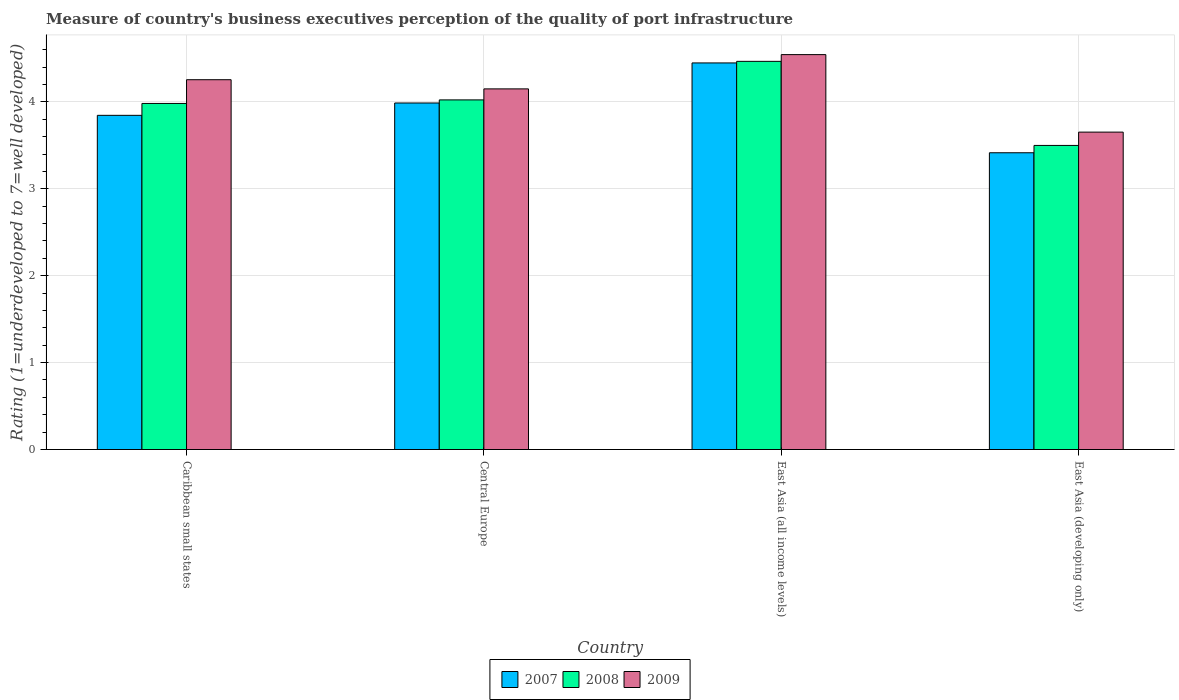How many groups of bars are there?
Your response must be concise. 4. How many bars are there on the 1st tick from the right?
Make the answer very short. 3. What is the label of the 4th group of bars from the left?
Give a very brief answer. East Asia (developing only). In how many cases, is the number of bars for a given country not equal to the number of legend labels?
Give a very brief answer. 0. What is the ratings of the quality of port infrastructure in 2008 in Caribbean small states?
Keep it short and to the point. 3.98. Across all countries, what is the maximum ratings of the quality of port infrastructure in 2007?
Make the answer very short. 4.45. Across all countries, what is the minimum ratings of the quality of port infrastructure in 2007?
Provide a succinct answer. 3.41. In which country was the ratings of the quality of port infrastructure in 2009 maximum?
Offer a terse response. East Asia (all income levels). In which country was the ratings of the quality of port infrastructure in 2007 minimum?
Make the answer very short. East Asia (developing only). What is the total ratings of the quality of port infrastructure in 2008 in the graph?
Your answer should be very brief. 15.97. What is the difference between the ratings of the quality of port infrastructure in 2009 in East Asia (all income levels) and that in East Asia (developing only)?
Provide a succinct answer. 0.89. What is the difference between the ratings of the quality of port infrastructure in 2007 in Central Europe and the ratings of the quality of port infrastructure in 2009 in East Asia (developing only)?
Your answer should be compact. 0.33. What is the average ratings of the quality of port infrastructure in 2008 per country?
Offer a very short reply. 3.99. What is the difference between the ratings of the quality of port infrastructure of/in 2009 and ratings of the quality of port infrastructure of/in 2008 in Caribbean small states?
Your response must be concise. 0.27. In how many countries, is the ratings of the quality of port infrastructure in 2009 greater than 2.8?
Offer a terse response. 4. What is the ratio of the ratings of the quality of port infrastructure in 2008 in Caribbean small states to that in Central Europe?
Provide a short and direct response. 0.99. What is the difference between the highest and the second highest ratings of the quality of port infrastructure in 2008?
Your answer should be compact. -0.48. What is the difference between the highest and the lowest ratings of the quality of port infrastructure in 2009?
Offer a very short reply. 0.89. What does the 3rd bar from the left in Central Europe represents?
Provide a short and direct response. 2009. What does the 2nd bar from the right in Central Europe represents?
Your answer should be very brief. 2008. Is it the case that in every country, the sum of the ratings of the quality of port infrastructure in 2009 and ratings of the quality of port infrastructure in 2007 is greater than the ratings of the quality of port infrastructure in 2008?
Your answer should be very brief. Yes. How many bars are there?
Keep it short and to the point. 12. How many countries are there in the graph?
Ensure brevity in your answer.  4. What is the difference between two consecutive major ticks on the Y-axis?
Offer a very short reply. 1. Does the graph contain any zero values?
Your answer should be compact. No. Does the graph contain grids?
Ensure brevity in your answer.  Yes. Where does the legend appear in the graph?
Your response must be concise. Bottom center. How are the legend labels stacked?
Offer a very short reply. Horizontal. What is the title of the graph?
Your response must be concise. Measure of country's business executives perception of the quality of port infrastructure. What is the label or title of the X-axis?
Make the answer very short. Country. What is the label or title of the Y-axis?
Offer a terse response. Rating (1=underdeveloped to 7=well developed). What is the Rating (1=underdeveloped to 7=well developed) of 2007 in Caribbean small states?
Offer a terse response. 3.85. What is the Rating (1=underdeveloped to 7=well developed) of 2008 in Caribbean small states?
Ensure brevity in your answer.  3.98. What is the Rating (1=underdeveloped to 7=well developed) in 2009 in Caribbean small states?
Your response must be concise. 4.26. What is the Rating (1=underdeveloped to 7=well developed) of 2007 in Central Europe?
Give a very brief answer. 3.99. What is the Rating (1=underdeveloped to 7=well developed) of 2008 in Central Europe?
Your response must be concise. 4.02. What is the Rating (1=underdeveloped to 7=well developed) of 2009 in Central Europe?
Provide a short and direct response. 4.15. What is the Rating (1=underdeveloped to 7=well developed) in 2007 in East Asia (all income levels)?
Provide a succinct answer. 4.45. What is the Rating (1=underdeveloped to 7=well developed) in 2008 in East Asia (all income levels)?
Keep it short and to the point. 4.47. What is the Rating (1=underdeveloped to 7=well developed) of 2009 in East Asia (all income levels)?
Your answer should be very brief. 4.54. What is the Rating (1=underdeveloped to 7=well developed) in 2007 in East Asia (developing only)?
Ensure brevity in your answer.  3.41. What is the Rating (1=underdeveloped to 7=well developed) in 2008 in East Asia (developing only)?
Keep it short and to the point. 3.5. What is the Rating (1=underdeveloped to 7=well developed) of 2009 in East Asia (developing only)?
Your answer should be compact. 3.65. Across all countries, what is the maximum Rating (1=underdeveloped to 7=well developed) in 2007?
Keep it short and to the point. 4.45. Across all countries, what is the maximum Rating (1=underdeveloped to 7=well developed) of 2008?
Offer a very short reply. 4.47. Across all countries, what is the maximum Rating (1=underdeveloped to 7=well developed) of 2009?
Offer a very short reply. 4.54. Across all countries, what is the minimum Rating (1=underdeveloped to 7=well developed) of 2007?
Give a very brief answer. 3.41. Across all countries, what is the minimum Rating (1=underdeveloped to 7=well developed) in 2008?
Offer a terse response. 3.5. Across all countries, what is the minimum Rating (1=underdeveloped to 7=well developed) in 2009?
Provide a succinct answer. 3.65. What is the total Rating (1=underdeveloped to 7=well developed) of 2007 in the graph?
Offer a very short reply. 15.7. What is the total Rating (1=underdeveloped to 7=well developed) in 2008 in the graph?
Your answer should be very brief. 15.97. What is the total Rating (1=underdeveloped to 7=well developed) of 2009 in the graph?
Provide a succinct answer. 16.6. What is the difference between the Rating (1=underdeveloped to 7=well developed) of 2007 in Caribbean small states and that in Central Europe?
Your answer should be compact. -0.14. What is the difference between the Rating (1=underdeveloped to 7=well developed) in 2008 in Caribbean small states and that in Central Europe?
Give a very brief answer. -0.04. What is the difference between the Rating (1=underdeveloped to 7=well developed) in 2009 in Caribbean small states and that in Central Europe?
Provide a succinct answer. 0.11. What is the difference between the Rating (1=underdeveloped to 7=well developed) in 2007 in Caribbean small states and that in East Asia (all income levels)?
Offer a very short reply. -0.6. What is the difference between the Rating (1=underdeveloped to 7=well developed) in 2008 in Caribbean small states and that in East Asia (all income levels)?
Keep it short and to the point. -0.48. What is the difference between the Rating (1=underdeveloped to 7=well developed) in 2009 in Caribbean small states and that in East Asia (all income levels)?
Provide a succinct answer. -0.29. What is the difference between the Rating (1=underdeveloped to 7=well developed) in 2007 in Caribbean small states and that in East Asia (developing only)?
Offer a very short reply. 0.43. What is the difference between the Rating (1=underdeveloped to 7=well developed) of 2008 in Caribbean small states and that in East Asia (developing only)?
Ensure brevity in your answer.  0.48. What is the difference between the Rating (1=underdeveloped to 7=well developed) of 2009 in Caribbean small states and that in East Asia (developing only)?
Give a very brief answer. 0.6. What is the difference between the Rating (1=underdeveloped to 7=well developed) in 2007 in Central Europe and that in East Asia (all income levels)?
Keep it short and to the point. -0.46. What is the difference between the Rating (1=underdeveloped to 7=well developed) in 2008 in Central Europe and that in East Asia (all income levels)?
Keep it short and to the point. -0.44. What is the difference between the Rating (1=underdeveloped to 7=well developed) of 2009 in Central Europe and that in East Asia (all income levels)?
Your response must be concise. -0.39. What is the difference between the Rating (1=underdeveloped to 7=well developed) of 2007 in Central Europe and that in East Asia (developing only)?
Ensure brevity in your answer.  0.57. What is the difference between the Rating (1=underdeveloped to 7=well developed) in 2008 in Central Europe and that in East Asia (developing only)?
Provide a short and direct response. 0.52. What is the difference between the Rating (1=underdeveloped to 7=well developed) in 2009 in Central Europe and that in East Asia (developing only)?
Provide a short and direct response. 0.5. What is the difference between the Rating (1=underdeveloped to 7=well developed) of 2007 in East Asia (all income levels) and that in East Asia (developing only)?
Your answer should be very brief. 1.03. What is the difference between the Rating (1=underdeveloped to 7=well developed) in 2008 in East Asia (all income levels) and that in East Asia (developing only)?
Keep it short and to the point. 0.97. What is the difference between the Rating (1=underdeveloped to 7=well developed) of 2009 in East Asia (all income levels) and that in East Asia (developing only)?
Keep it short and to the point. 0.89. What is the difference between the Rating (1=underdeveloped to 7=well developed) in 2007 in Caribbean small states and the Rating (1=underdeveloped to 7=well developed) in 2008 in Central Europe?
Provide a short and direct response. -0.18. What is the difference between the Rating (1=underdeveloped to 7=well developed) of 2007 in Caribbean small states and the Rating (1=underdeveloped to 7=well developed) of 2009 in Central Europe?
Provide a succinct answer. -0.3. What is the difference between the Rating (1=underdeveloped to 7=well developed) in 2008 in Caribbean small states and the Rating (1=underdeveloped to 7=well developed) in 2009 in Central Europe?
Your answer should be compact. -0.17. What is the difference between the Rating (1=underdeveloped to 7=well developed) of 2007 in Caribbean small states and the Rating (1=underdeveloped to 7=well developed) of 2008 in East Asia (all income levels)?
Provide a succinct answer. -0.62. What is the difference between the Rating (1=underdeveloped to 7=well developed) in 2007 in Caribbean small states and the Rating (1=underdeveloped to 7=well developed) in 2009 in East Asia (all income levels)?
Provide a short and direct response. -0.7. What is the difference between the Rating (1=underdeveloped to 7=well developed) in 2008 in Caribbean small states and the Rating (1=underdeveloped to 7=well developed) in 2009 in East Asia (all income levels)?
Offer a very short reply. -0.56. What is the difference between the Rating (1=underdeveloped to 7=well developed) of 2007 in Caribbean small states and the Rating (1=underdeveloped to 7=well developed) of 2008 in East Asia (developing only)?
Make the answer very short. 0.35. What is the difference between the Rating (1=underdeveloped to 7=well developed) in 2007 in Caribbean small states and the Rating (1=underdeveloped to 7=well developed) in 2009 in East Asia (developing only)?
Give a very brief answer. 0.19. What is the difference between the Rating (1=underdeveloped to 7=well developed) in 2008 in Caribbean small states and the Rating (1=underdeveloped to 7=well developed) in 2009 in East Asia (developing only)?
Offer a very short reply. 0.33. What is the difference between the Rating (1=underdeveloped to 7=well developed) in 2007 in Central Europe and the Rating (1=underdeveloped to 7=well developed) in 2008 in East Asia (all income levels)?
Your response must be concise. -0.48. What is the difference between the Rating (1=underdeveloped to 7=well developed) in 2007 in Central Europe and the Rating (1=underdeveloped to 7=well developed) in 2009 in East Asia (all income levels)?
Your response must be concise. -0.56. What is the difference between the Rating (1=underdeveloped to 7=well developed) in 2008 in Central Europe and the Rating (1=underdeveloped to 7=well developed) in 2009 in East Asia (all income levels)?
Provide a succinct answer. -0.52. What is the difference between the Rating (1=underdeveloped to 7=well developed) in 2007 in Central Europe and the Rating (1=underdeveloped to 7=well developed) in 2008 in East Asia (developing only)?
Your response must be concise. 0.49. What is the difference between the Rating (1=underdeveloped to 7=well developed) of 2007 in Central Europe and the Rating (1=underdeveloped to 7=well developed) of 2009 in East Asia (developing only)?
Give a very brief answer. 0.34. What is the difference between the Rating (1=underdeveloped to 7=well developed) of 2008 in Central Europe and the Rating (1=underdeveloped to 7=well developed) of 2009 in East Asia (developing only)?
Offer a very short reply. 0.37. What is the difference between the Rating (1=underdeveloped to 7=well developed) of 2007 in East Asia (all income levels) and the Rating (1=underdeveloped to 7=well developed) of 2008 in East Asia (developing only)?
Your answer should be very brief. 0.95. What is the difference between the Rating (1=underdeveloped to 7=well developed) in 2007 in East Asia (all income levels) and the Rating (1=underdeveloped to 7=well developed) in 2009 in East Asia (developing only)?
Your response must be concise. 0.8. What is the difference between the Rating (1=underdeveloped to 7=well developed) in 2008 in East Asia (all income levels) and the Rating (1=underdeveloped to 7=well developed) in 2009 in East Asia (developing only)?
Offer a terse response. 0.81. What is the average Rating (1=underdeveloped to 7=well developed) of 2007 per country?
Keep it short and to the point. 3.92. What is the average Rating (1=underdeveloped to 7=well developed) in 2008 per country?
Offer a terse response. 3.99. What is the average Rating (1=underdeveloped to 7=well developed) of 2009 per country?
Offer a very short reply. 4.15. What is the difference between the Rating (1=underdeveloped to 7=well developed) of 2007 and Rating (1=underdeveloped to 7=well developed) of 2008 in Caribbean small states?
Offer a very short reply. -0.14. What is the difference between the Rating (1=underdeveloped to 7=well developed) in 2007 and Rating (1=underdeveloped to 7=well developed) in 2009 in Caribbean small states?
Offer a very short reply. -0.41. What is the difference between the Rating (1=underdeveloped to 7=well developed) of 2008 and Rating (1=underdeveloped to 7=well developed) of 2009 in Caribbean small states?
Provide a succinct answer. -0.27. What is the difference between the Rating (1=underdeveloped to 7=well developed) in 2007 and Rating (1=underdeveloped to 7=well developed) in 2008 in Central Europe?
Offer a terse response. -0.04. What is the difference between the Rating (1=underdeveloped to 7=well developed) in 2007 and Rating (1=underdeveloped to 7=well developed) in 2009 in Central Europe?
Ensure brevity in your answer.  -0.16. What is the difference between the Rating (1=underdeveloped to 7=well developed) of 2008 and Rating (1=underdeveloped to 7=well developed) of 2009 in Central Europe?
Your response must be concise. -0.13. What is the difference between the Rating (1=underdeveloped to 7=well developed) of 2007 and Rating (1=underdeveloped to 7=well developed) of 2008 in East Asia (all income levels)?
Keep it short and to the point. -0.02. What is the difference between the Rating (1=underdeveloped to 7=well developed) in 2007 and Rating (1=underdeveloped to 7=well developed) in 2009 in East Asia (all income levels)?
Provide a succinct answer. -0.1. What is the difference between the Rating (1=underdeveloped to 7=well developed) in 2008 and Rating (1=underdeveloped to 7=well developed) in 2009 in East Asia (all income levels)?
Ensure brevity in your answer.  -0.08. What is the difference between the Rating (1=underdeveloped to 7=well developed) of 2007 and Rating (1=underdeveloped to 7=well developed) of 2008 in East Asia (developing only)?
Make the answer very short. -0.08. What is the difference between the Rating (1=underdeveloped to 7=well developed) in 2007 and Rating (1=underdeveloped to 7=well developed) in 2009 in East Asia (developing only)?
Your answer should be very brief. -0.24. What is the difference between the Rating (1=underdeveloped to 7=well developed) of 2008 and Rating (1=underdeveloped to 7=well developed) of 2009 in East Asia (developing only)?
Give a very brief answer. -0.15. What is the ratio of the Rating (1=underdeveloped to 7=well developed) in 2007 in Caribbean small states to that in Central Europe?
Your answer should be compact. 0.96. What is the ratio of the Rating (1=underdeveloped to 7=well developed) of 2008 in Caribbean small states to that in Central Europe?
Offer a very short reply. 0.99. What is the ratio of the Rating (1=underdeveloped to 7=well developed) in 2009 in Caribbean small states to that in Central Europe?
Offer a very short reply. 1.03. What is the ratio of the Rating (1=underdeveloped to 7=well developed) of 2007 in Caribbean small states to that in East Asia (all income levels)?
Offer a terse response. 0.86. What is the ratio of the Rating (1=underdeveloped to 7=well developed) in 2008 in Caribbean small states to that in East Asia (all income levels)?
Make the answer very short. 0.89. What is the ratio of the Rating (1=underdeveloped to 7=well developed) in 2009 in Caribbean small states to that in East Asia (all income levels)?
Your answer should be very brief. 0.94. What is the ratio of the Rating (1=underdeveloped to 7=well developed) in 2007 in Caribbean small states to that in East Asia (developing only)?
Make the answer very short. 1.13. What is the ratio of the Rating (1=underdeveloped to 7=well developed) in 2008 in Caribbean small states to that in East Asia (developing only)?
Keep it short and to the point. 1.14. What is the ratio of the Rating (1=underdeveloped to 7=well developed) of 2009 in Caribbean small states to that in East Asia (developing only)?
Your response must be concise. 1.17. What is the ratio of the Rating (1=underdeveloped to 7=well developed) of 2007 in Central Europe to that in East Asia (all income levels)?
Offer a terse response. 0.9. What is the ratio of the Rating (1=underdeveloped to 7=well developed) in 2008 in Central Europe to that in East Asia (all income levels)?
Make the answer very short. 0.9. What is the ratio of the Rating (1=underdeveloped to 7=well developed) of 2009 in Central Europe to that in East Asia (all income levels)?
Give a very brief answer. 0.91. What is the ratio of the Rating (1=underdeveloped to 7=well developed) of 2007 in Central Europe to that in East Asia (developing only)?
Your answer should be compact. 1.17. What is the ratio of the Rating (1=underdeveloped to 7=well developed) in 2008 in Central Europe to that in East Asia (developing only)?
Make the answer very short. 1.15. What is the ratio of the Rating (1=underdeveloped to 7=well developed) in 2009 in Central Europe to that in East Asia (developing only)?
Your answer should be very brief. 1.14. What is the ratio of the Rating (1=underdeveloped to 7=well developed) in 2007 in East Asia (all income levels) to that in East Asia (developing only)?
Your answer should be very brief. 1.3. What is the ratio of the Rating (1=underdeveloped to 7=well developed) in 2008 in East Asia (all income levels) to that in East Asia (developing only)?
Your answer should be very brief. 1.28. What is the ratio of the Rating (1=underdeveloped to 7=well developed) in 2009 in East Asia (all income levels) to that in East Asia (developing only)?
Ensure brevity in your answer.  1.24. What is the difference between the highest and the second highest Rating (1=underdeveloped to 7=well developed) in 2007?
Your answer should be very brief. 0.46. What is the difference between the highest and the second highest Rating (1=underdeveloped to 7=well developed) in 2008?
Offer a very short reply. 0.44. What is the difference between the highest and the second highest Rating (1=underdeveloped to 7=well developed) in 2009?
Provide a short and direct response. 0.29. What is the difference between the highest and the lowest Rating (1=underdeveloped to 7=well developed) of 2007?
Offer a very short reply. 1.03. What is the difference between the highest and the lowest Rating (1=underdeveloped to 7=well developed) in 2008?
Provide a succinct answer. 0.97. What is the difference between the highest and the lowest Rating (1=underdeveloped to 7=well developed) of 2009?
Your answer should be compact. 0.89. 